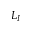<formula> <loc_0><loc_0><loc_500><loc_500>L _ { I }</formula> 